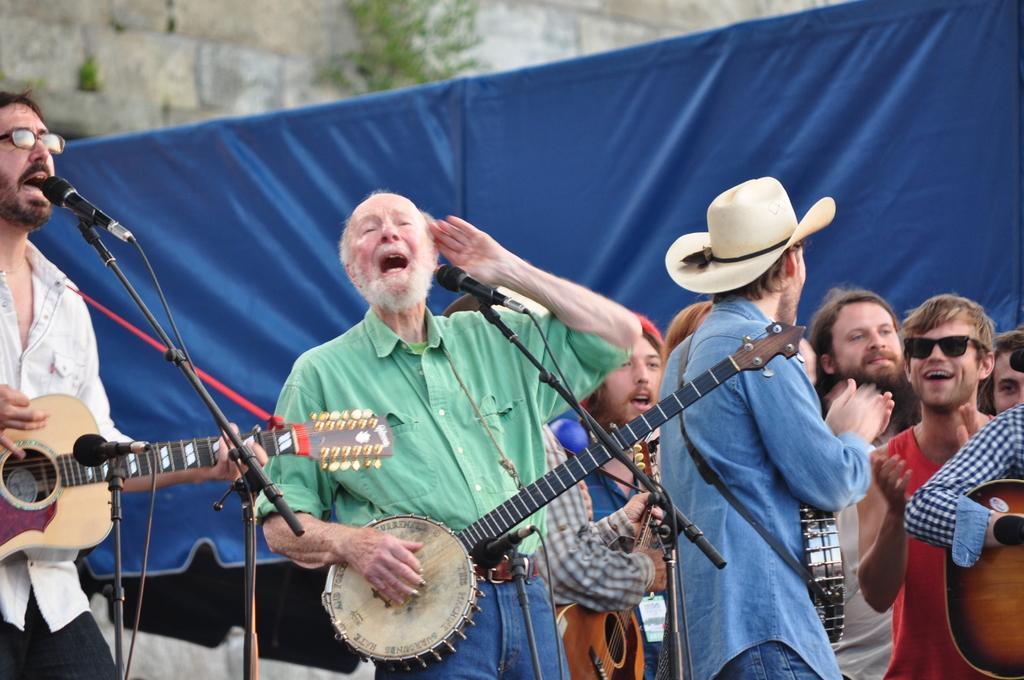Please provide a concise description of this image. In the image we can see there are people who are standing and holding musical instruments in their hand such as guitar and the man is wearing hat and at the back there is a blue colour curtain. 